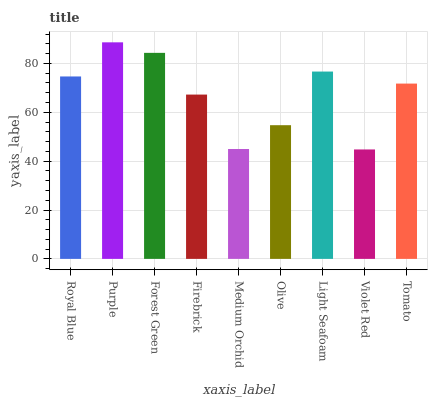Is Forest Green the minimum?
Answer yes or no. No. Is Forest Green the maximum?
Answer yes or no. No. Is Purple greater than Forest Green?
Answer yes or no. Yes. Is Forest Green less than Purple?
Answer yes or no. Yes. Is Forest Green greater than Purple?
Answer yes or no. No. Is Purple less than Forest Green?
Answer yes or no. No. Is Tomato the high median?
Answer yes or no. Yes. Is Tomato the low median?
Answer yes or no. Yes. Is Light Seafoam the high median?
Answer yes or no. No. Is Violet Red the low median?
Answer yes or no. No. 